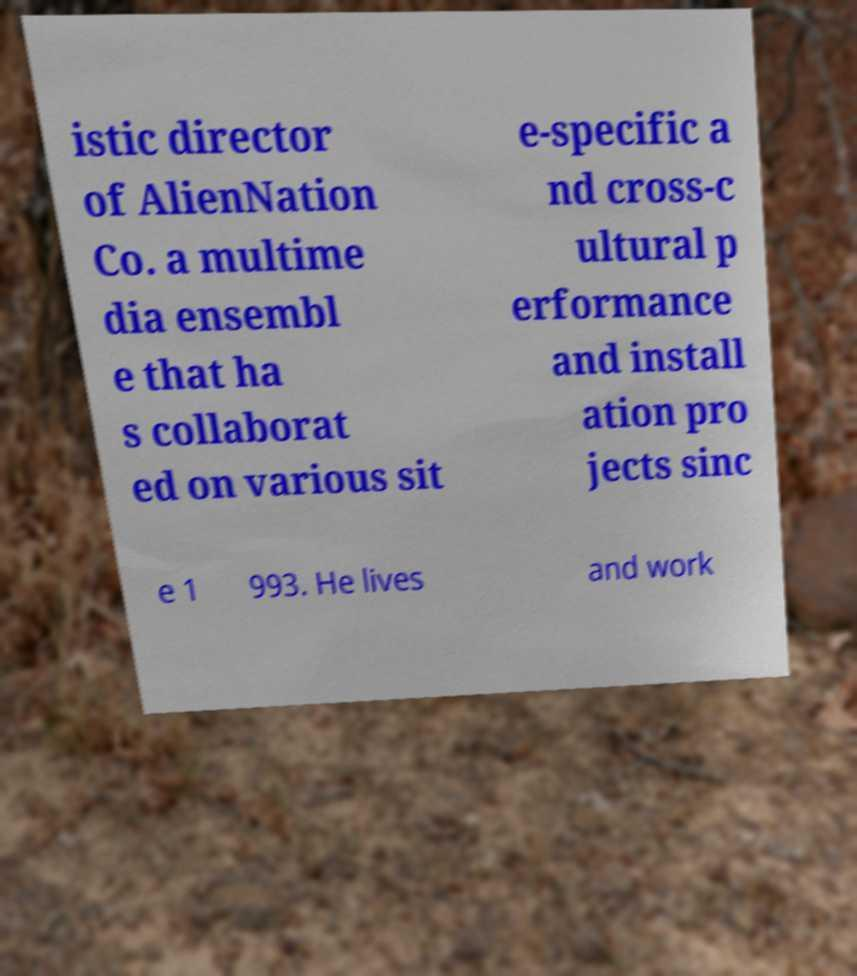Could you extract and type out the text from this image? istic director of AlienNation Co. a multime dia ensembl e that ha s collaborat ed on various sit e-specific a nd cross-c ultural p erformance and install ation pro jects sinc e 1 993. He lives and work 